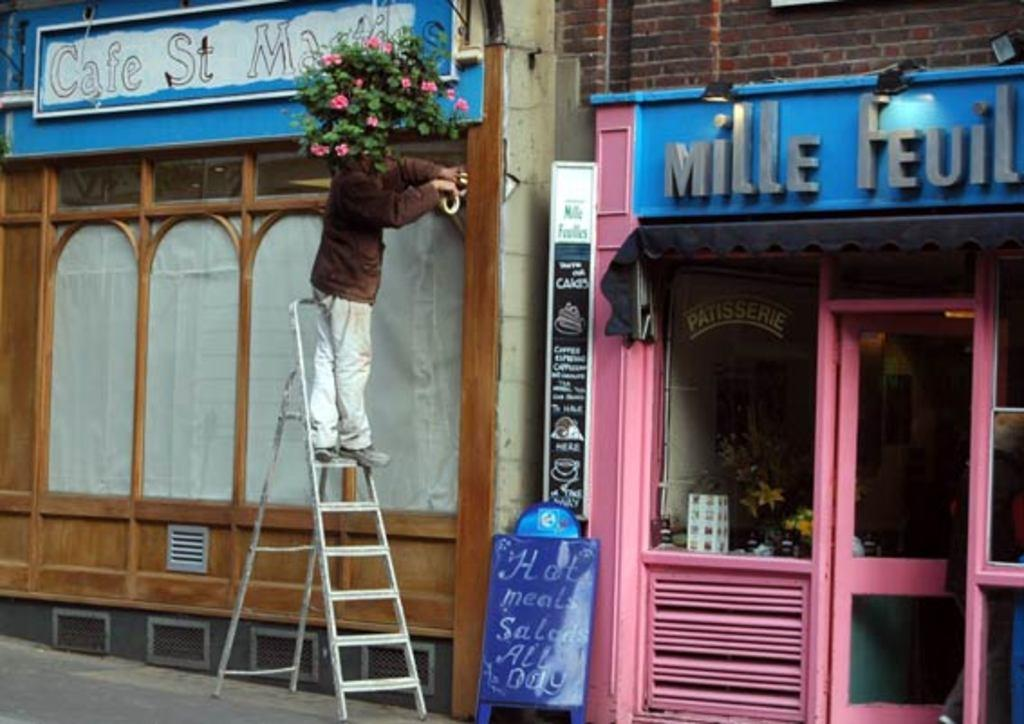Provide a one-sentence caption for the provided image. A store front with the word "Mille" above it. 